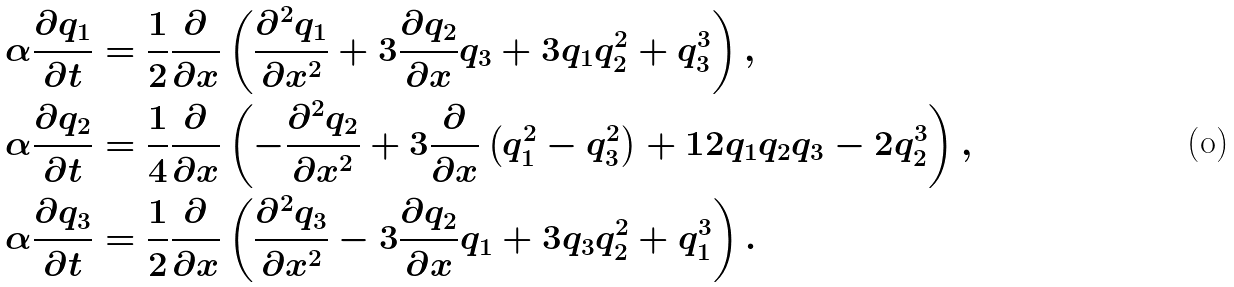Convert formula to latex. <formula><loc_0><loc_0><loc_500><loc_500>\alpha \frac { \partial q _ { 1 } } { \partial t } & = \frac { 1 } { 2 } \frac { \partial } { \partial x } \left ( \frac { \partial ^ { 2 } q _ { 1 } } { \partial x ^ { 2 } } + 3 \frac { \partial q _ { 2 } } { \partial x } q _ { 3 } + 3 q _ { 1 } q _ { 2 } ^ { 2 } + q _ { 3 } ^ { 3 } \right ) , \\ \alpha \frac { \partial q _ { 2 } } { \partial t } & = \frac { 1 } { 4 } \frac { \partial } { \partial x } \left ( - \frac { \partial ^ { 2 } q _ { 2 } } { \partial x ^ { 2 } } + 3 \frac { \partial } { \partial x } \left ( q _ { 1 } ^ { 2 } - q _ { 3 } ^ { 2 } \right ) + 1 2 q _ { 1 } q _ { 2 } q _ { 3 } - 2 q _ { 2 } ^ { 3 } \right ) , \\ \alpha \frac { \partial q _ { 3 } } { \partial t } & = \frac { 1 } { 2 } \frac { \partial } { \partial x } \left ( \frac { \partial ^ { 2 } q _ { 3 } } { \partial x ^ { 2 } } - 3 \frac { \partial q _ { 2 } } { \partial x } q _ { 1 } + 3 q _ { 3 } q _ { 2 } ^ { 2 } + q _ { 1 } ^ { 3 } \right ) .</formula> 